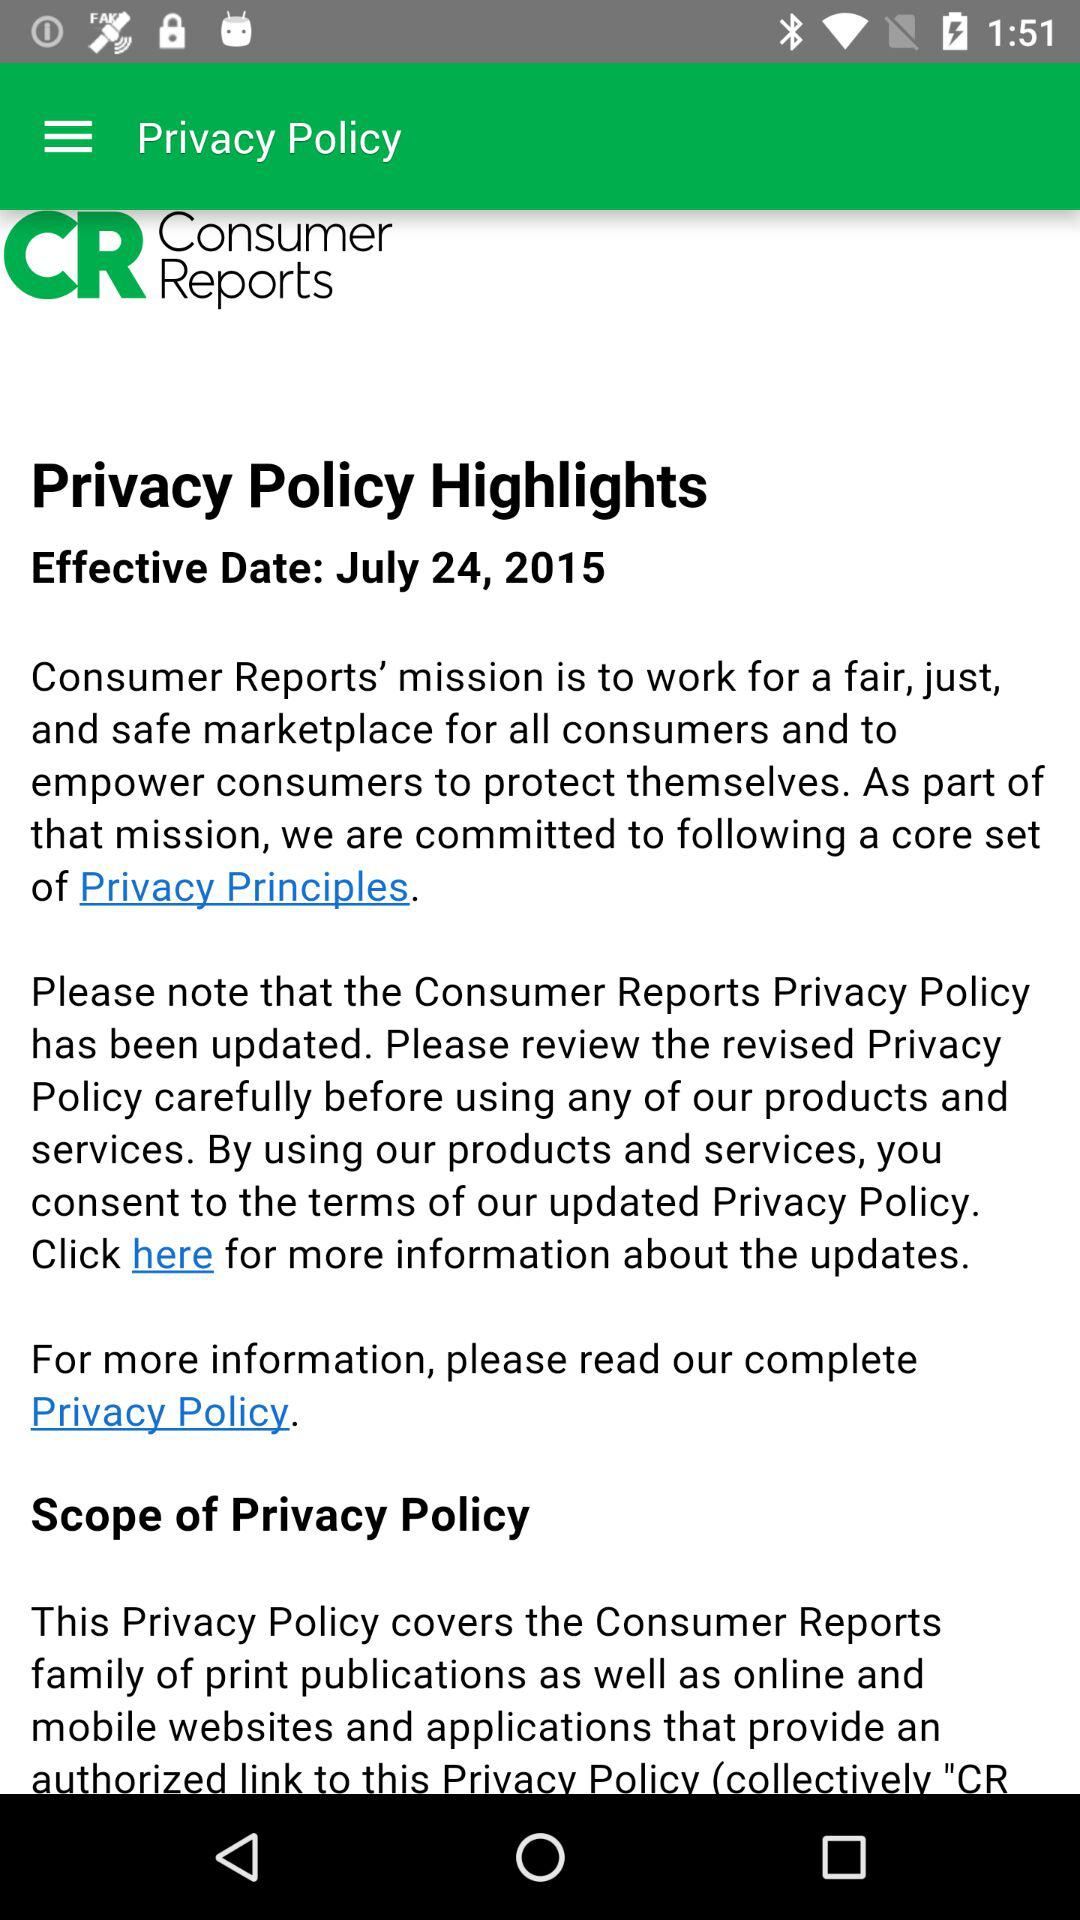What is the application's version?
When the provided information is insufficient, respond with <no answer>. <no answer> 